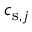<formula> <loc_0><loc_0><loc_500><loc_500>c _ { s , j }</formula> 